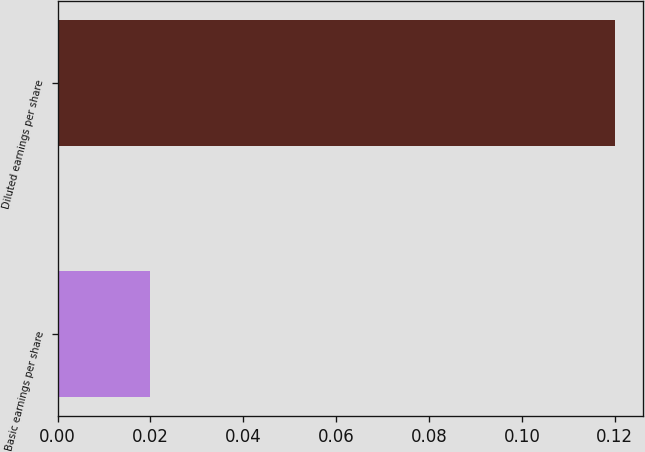<chart> <loc_0><loc_0><loc_500><loc_500><bar_chart><fcel>Basic earnings per share<fcel>Diluted earnings per share<nl><fcel>0.02<fcel>0.12<nl></chart> 